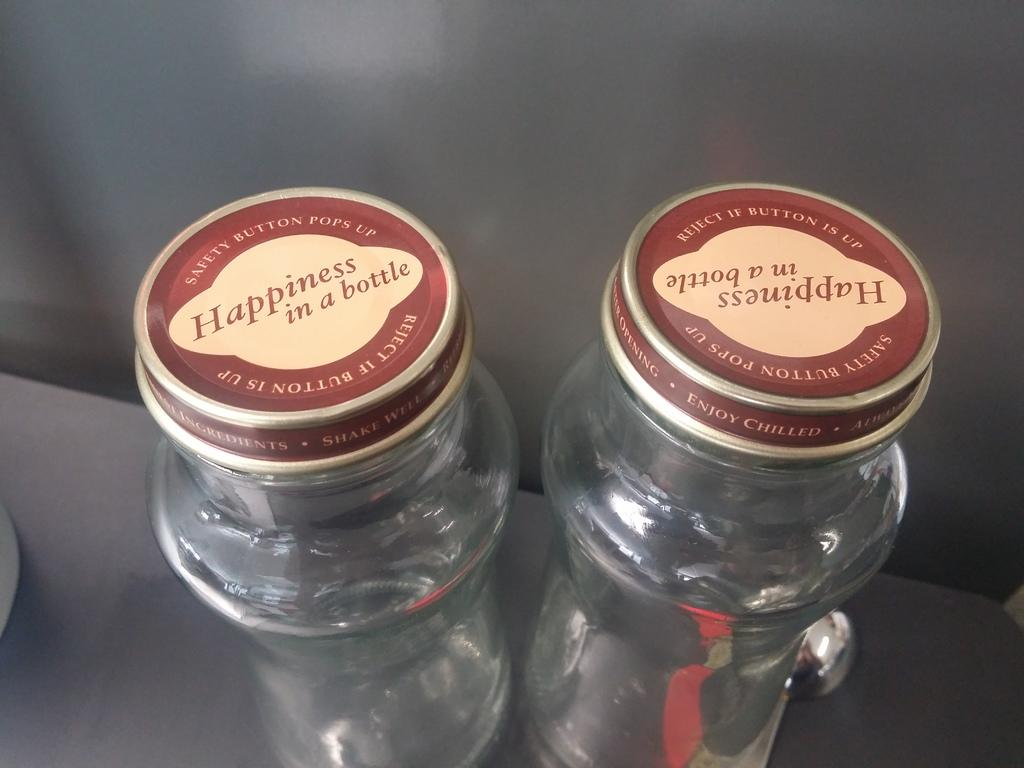<image>
Give a short and clear explanation of the subsequent image. Two empty jars with lids that say happiness in a bottle with a safety button lid. 